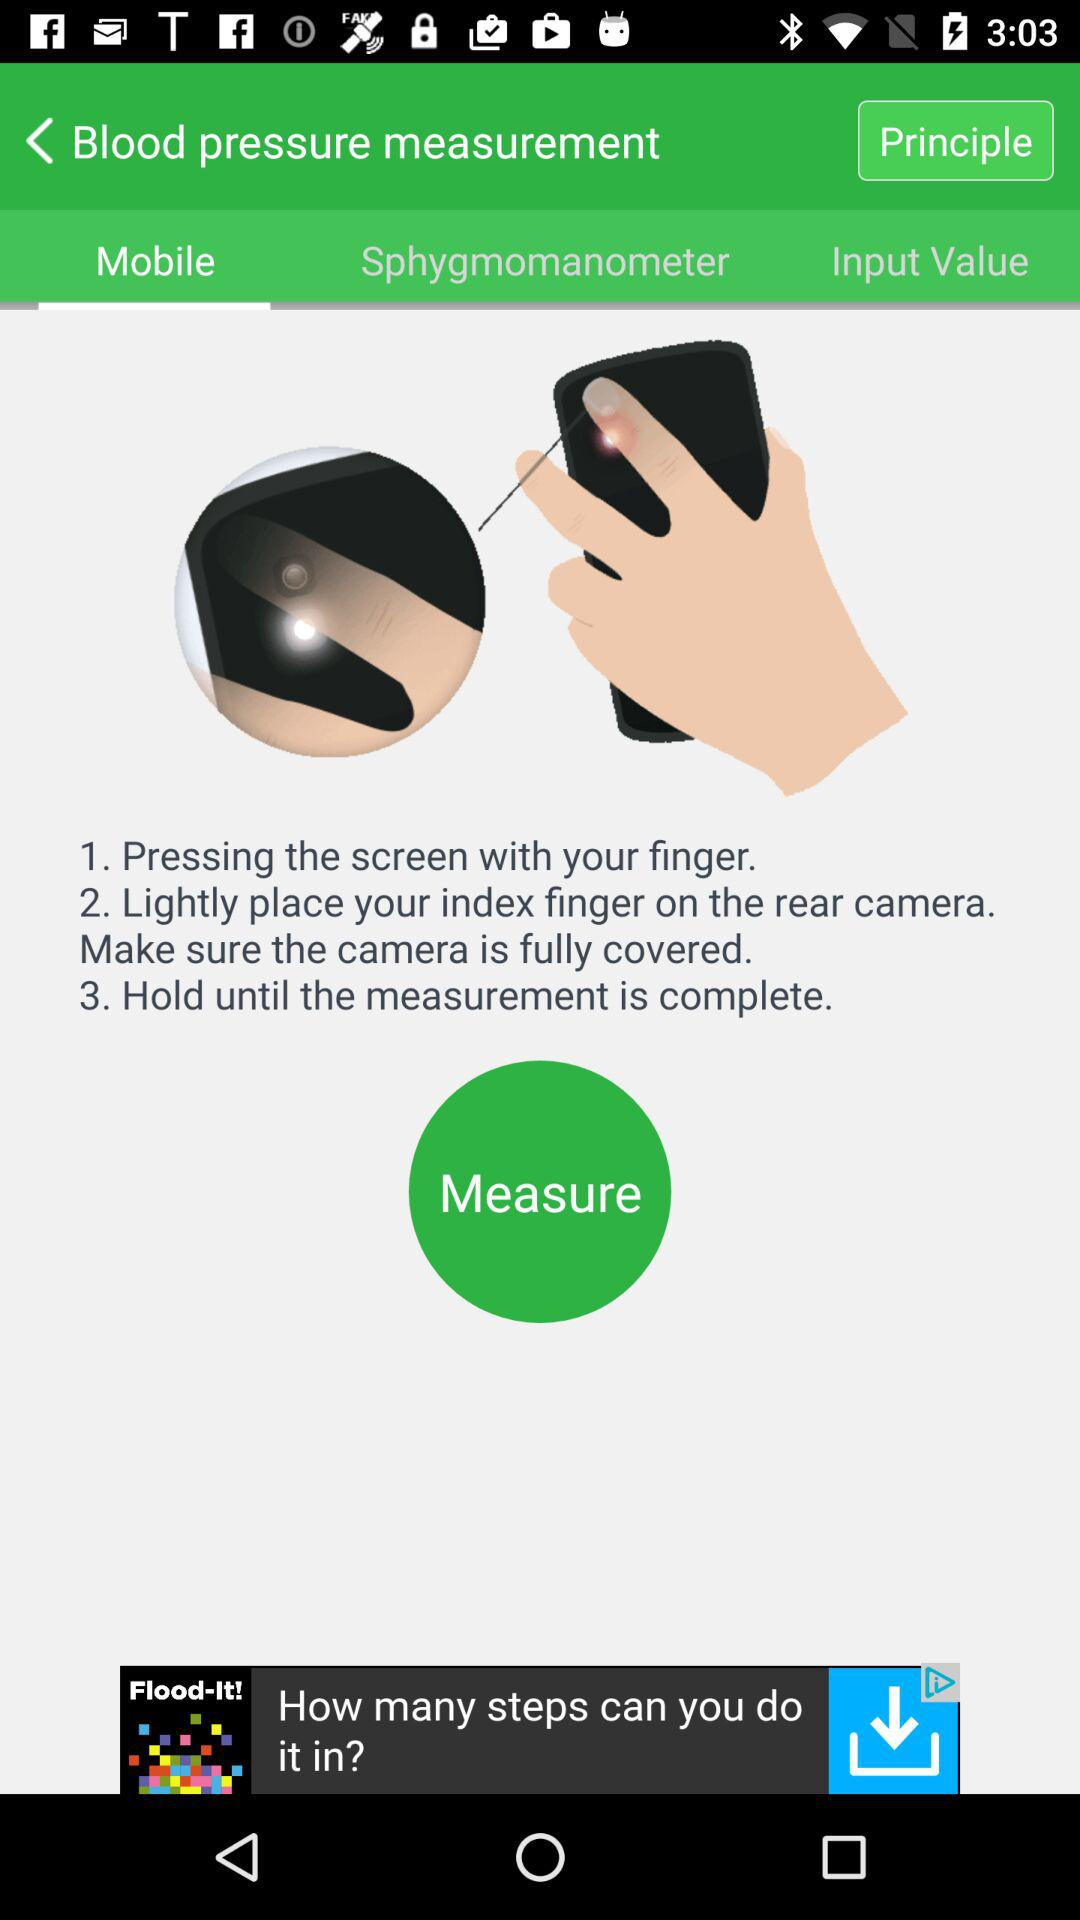Which finger should we place on the rear camera? You should place your index finger on the rear camera. 